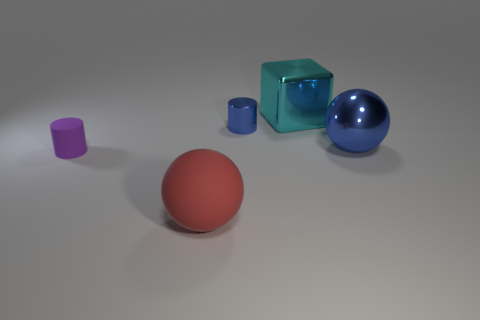Add 1 big cyan rubber cylinders. How many objects exist? 6 Subtract all spheres. How many objects are left? 3 Add 1 small blue cylinders. How many small blue cylinders are left? 2 Add 5 rubber cylinders. How many rubber cylinders exist? 6 Subtract 0 brown cylinders. How many objects are left? 5 Subtract all balls. Subtract all red balls. How many objects are left? 2 